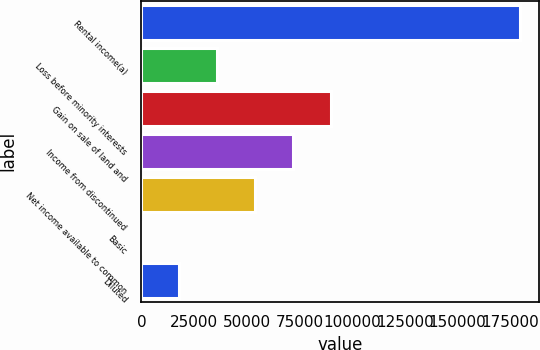Convert chart. <chart><loc_0><loc_0><loc_500><loc_500><bar_chart><fcel>Rental income(a)<fcel>Loss before minority interests<fcel>Gain on sale of land and<fcel>Income from discontinued<fcel>Net income available to common<fcel>Basic<fcel>Diluted<nl><fcel>179749<fcel>35949.9<fcel>89874.6<fcel>71899.7<fcel>53924.8<fcel>0.16<fcel>17975<nl></chart> 